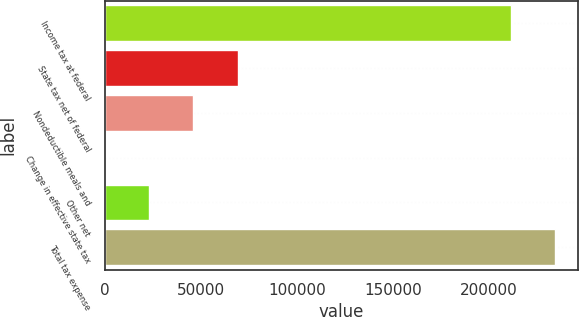Convert chart to OTSL. <chart><loc_0><loc_0><loc_500><loc_500><bar_chart><fcel>Income tax at federal<fcel>State tax net of federal<fcel>Nondeductible meals and<fcel>Change in effective state tax<fcel>Other net<fcel>Total tax expense<nl><fcel>211610<fcel>69121.9<fcel>46166.6<fcel>256<fcel>23211.3<fcel>234565<nl></chart> 